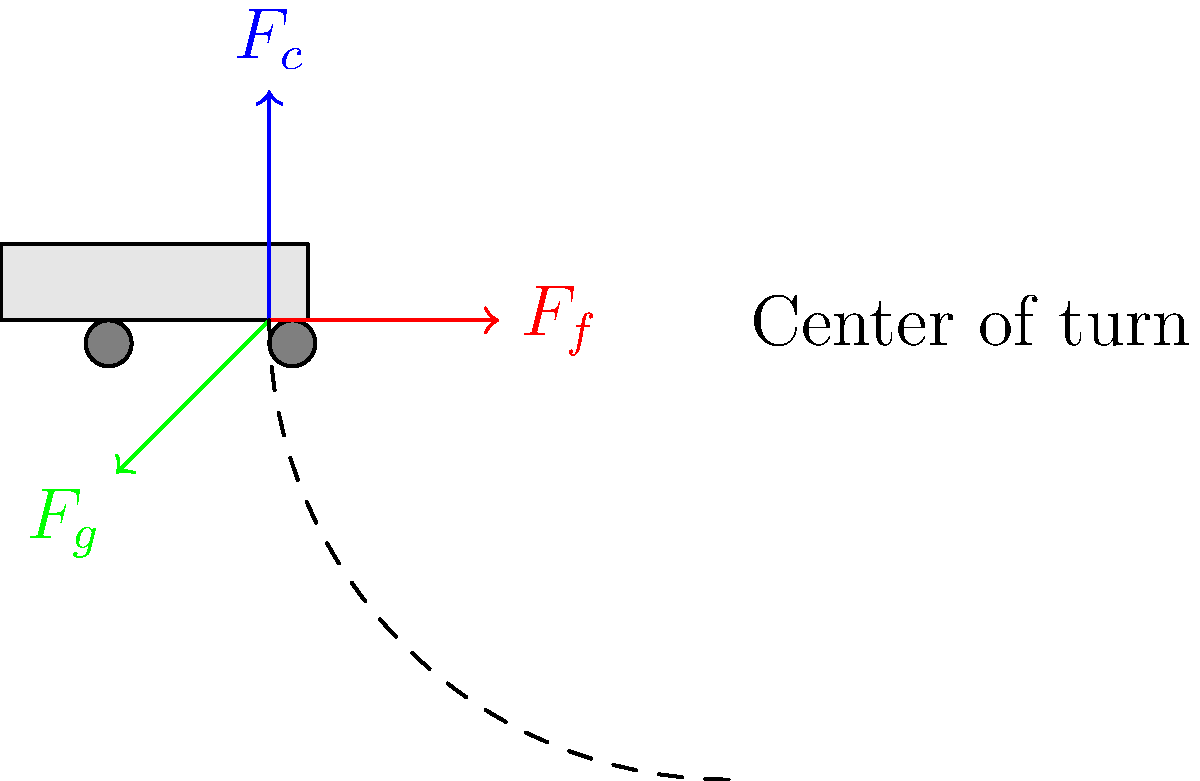Consider a car making a left turn on a flat, horizontal road. The free-body diagram shows the main forces acting on the car during the turn. Identify these forces and explain how they contribute to the car's circular motion. What would happen if the centripetal force ($F_c$) were to suddenly decrease? To understand the forces acting on a car while cornering, let's break down the free-body diagram:

1. $F_c$ (blue arrow pointing upward): This is the centripetal force, which is responsible for the car's circular motion. It's provided by the friction between the tires and the road.

2. $F_f$ (red arrow pointing right): This is the friction force, which opposes the car's tendency to slide outward during the turn. It's also crucial for maintaining traction.

3. $F_g$ (green arrow pointing down and left): This represents the gravitational force acting on the car.

The centripetal force ($F_c$) is the key to the car's circular motion. It's calculated as:

$$ F_c = \frac{mv^2}{r} $$

Where $m$ is the mass of the car, $v$ is its velocity, and $r$ is the radius of the turn.

The friction force ($F_f$) provides the necessary centripetal force for turning. Without it, the car would continue in a straight line (tangent to the curve).

If the centripetal force were to suddenly decrease:

1. The car would follow a path with a larger radius of curvature.
2. If the decrease is significant, the car might not complete the turn and could potentially skid off the road.
3. This could happen due to reduced friction (e.g., wet or icy roads) or excessive speed for the given turn radius.

To maintain a safe turn, drivers must:
1. Adjust speed appropriately for the turn radius.
2. Ensure proper tire condition for adequate friction.
3. Be aware of road conditions that might affect the available friction.
Answer: If centripetal force decreases, the car would follow a wider turn or potentially skid off the road. 